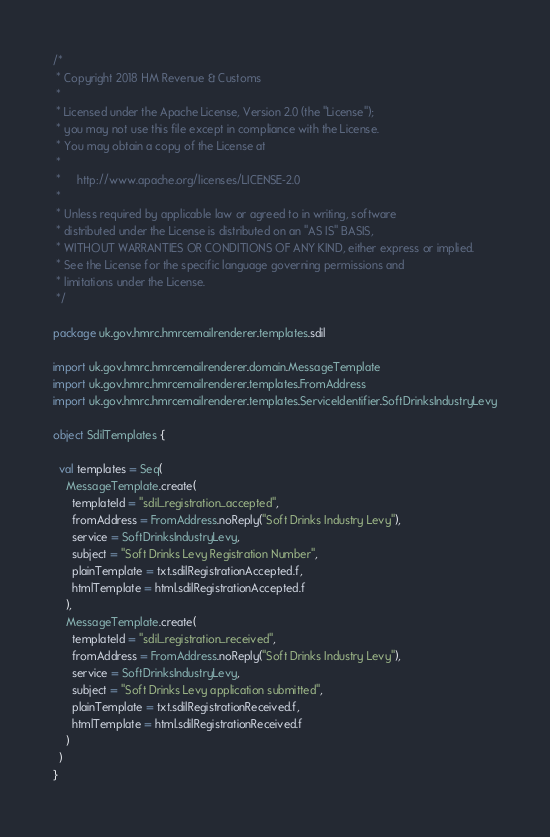<code> <loc_0><loc_0><loc_500><loc_500><_Scala_>/*
 * Copyright 2018 HM Revenue & Customs
 *
 * Licensed under the Apache License, Version 2.0 (the "License");
 * you may not use this file except in compliance with the License.
 * You may obtain a copy of the License at
 *
 *     http://www.apache.org/licenses/LICENSE-2.0
 *
 * Unless required by applicable law or agreed to in writing, software
 * distributed under the License is distributed on an "AS IS" BASIS,
 * WITHOUT WARRANTIES OR CONDITIONS OF ANY KIND, either express or implied.
 * See the License for the specific language governing permissions and
 * limitations under the License.
 */

package uk.gov.hmrc.hmrcemailrenderer.templates.sdil

import uk.gov.hmrc.hmrcemailrenderer.domain.MessageTemplate
import uk.gov.hmrc.hmrcemailrenderer.templates.FromAddress
import uk.gov.hmrc.hmrcemailrenderer.templates.ServiceIdentifier.SoftDrinksIndustryLevy

object SdilTemplates {

  val templates = Seq(
    MessageTemplate.create(
      templateId = "sdil_registration_accepted",
      fromAddress = FromAddress.noReply("Soft Drinks Industry Levy"),
      service = SoftDrinksIndustryLevy,
      subject = "Soft Drinks Levy Registration Number",
      plainTemplate = txt.sdilRegistrationAccepted.f,
      htmlTemplate = html.sdilRegistrationAccepted.f
    ),
    MessageTemplate.create(
      templateId = "sdil_registration_received",
      fromAddress = FromAddress.noReply("Soft Drinks Industry Levy"),
      service = SoftDrinksIndustryLevy,
      subject = "Soft Drinks Levy application submitted",
      plainTemplate = txt.sdilRegistrationReceived.f,
      htmlTemplate = html.sdilRegistrationReceived.f
    )
  )
}
</code> 